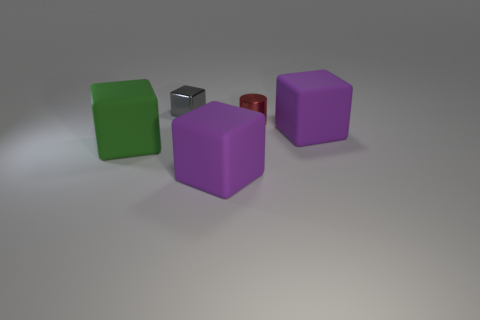Does the cylinder have the same color as the metallic cube?
Offer a terse response. No. How many cubes are behind the large green block and to the left of the red shiny thing?
Give a very brief answer. 1. What number of tiny metallic cylinders are left of the large purple rubber thing that is to the right of the matte block in front of the green rubber block?
Give a very brief answer. 1. The tiny gray shiny thing is what shape?
Give a very brief answer. Cube. How many large cubes have the same material as the gray object?
Provide a succinct answer. 0. There is a block that is made of the same material as the red cylinder; what is its color?
Give a very brief answer. Gray. There is a cylinder; does it have the same size as the purple block on the left side of the tiny red shiny cylinder?
Keep it short and to the point. No. What material is the small thing in front of the gray thing behind the big cube left of the small gray thing?
Offer a terse response. Metal. How many things are either gray matte cubes or purple matte cubes?
Ensure brevity in your answer.  2. Do the large cube behind the green matte cube and the small object that is on the right side of the small gray shiny thing have the same color?
Make the answer very short. No. 